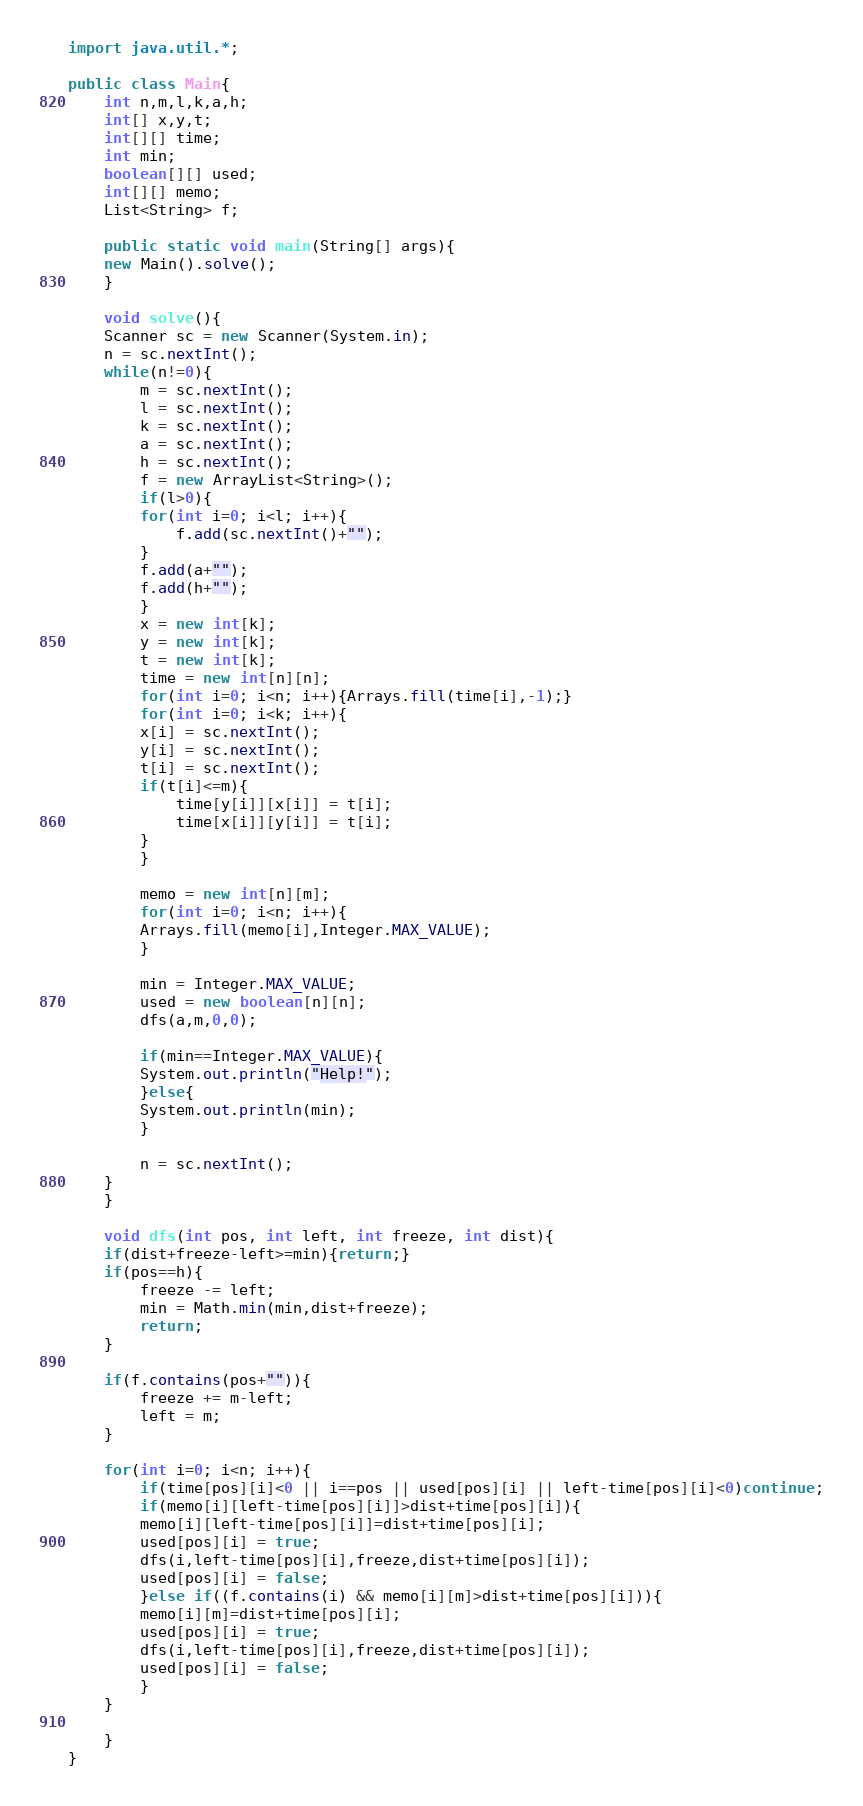<code> <loc_0><loc_0><loc_500><loc_500><_Java_>import java.util.*;

public class Main{
    int n,m,l,k,a,h;
    int[] x,y,t;
    int[][] time;
    int min;
    boolean[][] used;
    int[][] memo;
    List<String> f;

    public static void main(String[] args){
	new Main().solve();
    }

    void solve(){
	Scanner sc = new Scanner(System.in);
	n = sc.nextInt();
	while(n!=0){
	    m = sc.nextInt();
	    l = sc.nextInt();
	    k = sc.nextInt();
	    a = sc.nextInt();
	    h = sc.nextInt();
	    f = new ArrayList<String>();
	    if(l>0){
		for(int i=0; i<l; i++){
		    f.add(sc.nextInt()+"");
		}
		f.add(a+"");
		f.add(h+"");
	    }
	    x = new int[k];
	    y = new int[k];
	    t = new int[k];
	    time = new int[n][n];
	    for(int i=0; i<n; i++){Arrays.fill(time[i],-1);}
	    for(int i=0; i<k; i++){
		x[i] = sc.nextInt();
		y[i] = sc.nextInt();
		t[i] = sc.nextInt();
		if(t[i]<=m){
		    time[y[i]][x[i]] = t[i];
		    time[x[i]][y[i]] = t[i];
		}
	    }

	    memo = new int[n][m];
	    for(int i=0; i<n; i++){
		Arrays.fill(memo[i],Integer.MAX_VALUE);
	    }

	    min = Integer.MAX_VALUE;
	    used = new boolean[n][n];
	    dfs(a,m,0,0);

	    if(min==Integer.MAX_VALUE){
		System.out.println("Help!");
	    }else{
		System.out.println(min);
	    }

	    n = sc.nextInt();
	}
    }

    void dfs(int pos, int left, int freeze, int dist){
	if(dist+freeze-left>=min){return;}
	if(pos==h){
	    freeze -= left;
	    min = Math.min(min,dist+freeze);
	    return;
	}

	if(f.contains(pos+"")){
	    freeze += m-left;
	    left = m;
	}

	for(int i=0; i<n; i++){
	    if(time[pos][i]<0 || i==pos || used[pos][i] || left-time[pos][i]<0)continue;
	    if(memo[i][left-time[pos][i]]>dist+time[pos][i]){
		memo[i][left-time[pos][i]]=dist+time[pos][i];
		used[pos][i] = true;
		dfs(i,left-time[pos][i],freeze,dist+time[pos][i]);
		used[pos][i] = false;
	    }else if((f.contains(i) && memo[i][m]>dist+time[pos][i])){
		memo[i][m]=dist+time[pos][i];
		used[pos][i] = true;
		dfs(i,left-time[pos][i],freeze,dist+time[pos][i]);
		used[pos][i] = false;
	    }
	}

    }
}</code> 